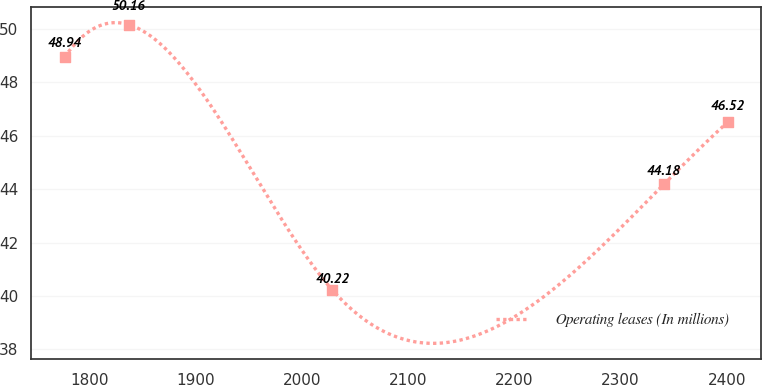Convert chart. <chart><loc_0><loc_0><loc_500><loc_500><line_chart><ecel><fcel>Operating leases (In millions)<nl><fcel>1776.25<fcel>48.94<nl><fcel>1836.69<fcel>50.16<nl><fcel>2028.63<fcel>40.22<nl><fcel>2340.65<fcel>44.18<nl><fcel>2401.09<fcel>46.52<nl></chart> 